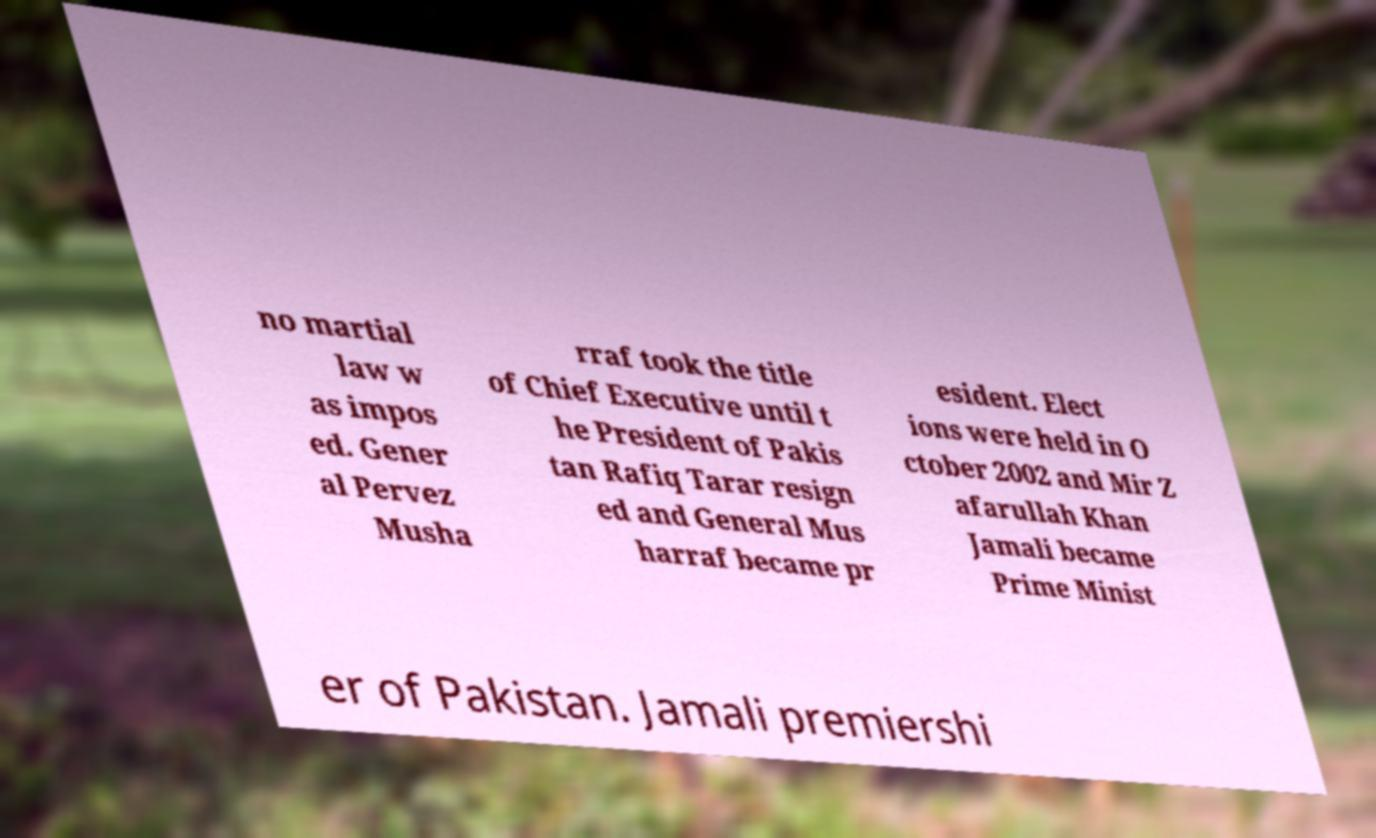Can you read and provide the text displayed in the image?This photo seems to have some interesting text. Can you extract and type it out for me? no martial law w as impos ed. Gener al Pervez Musha rraf took the title of Chief Executive until t he President of Pakis tan Rafiq Tarar resign ed and General Mus harraf became pr esident. Elect ions were held in O ctober 2002 and Mir Z afarullah Khan Jamali became Prime Minist er of Pakistan. Jamali premiershi 